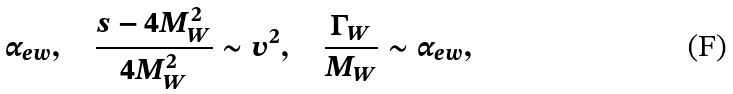<formula> <loc_0><loc_0><loc_500><loc_500>\alpha _ { e w } , \quad \frac { s - 4 M _ { W } ^ { 2 } } { 4 M _ { W } ^ { 2 } } \sim v ^ { 2 } , \quad \frac { \Gamma _ { W } } { M _ { W } } \sim \alpha _ { e w } ,</formula> 